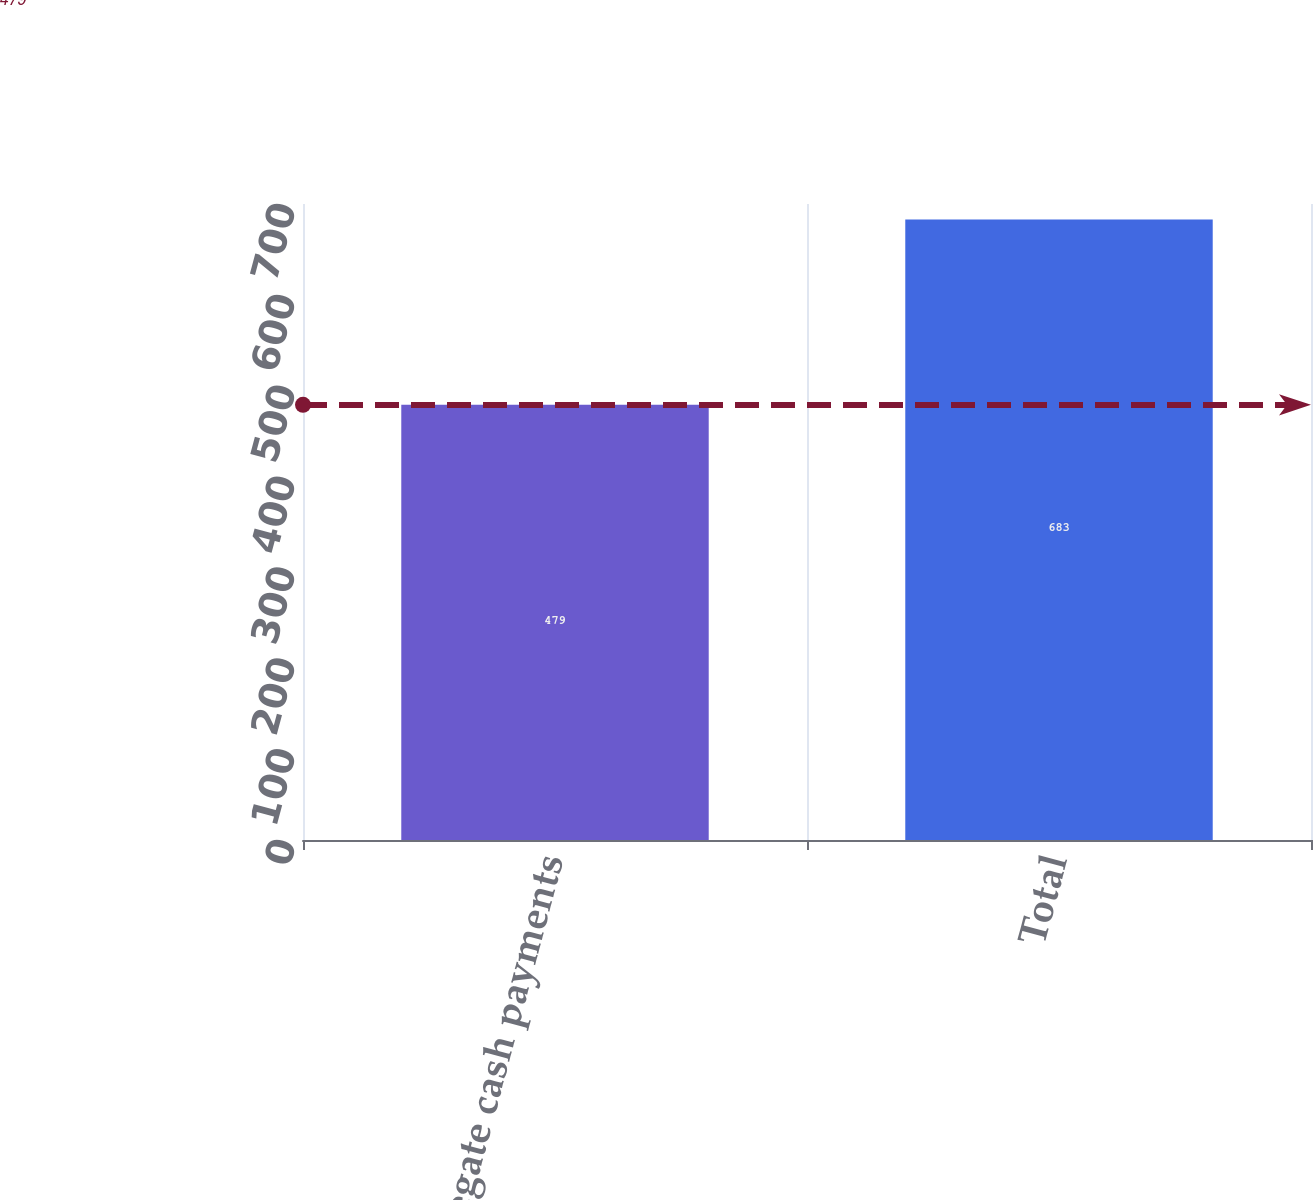Convert chart to OTSL. <chart><loc_0><loc_0><loc_500><loc_500><bar_chart><fcel>Aggregate cash payments<fcel>Total<nl><fcel>479<fcel>683<nl></chart> 